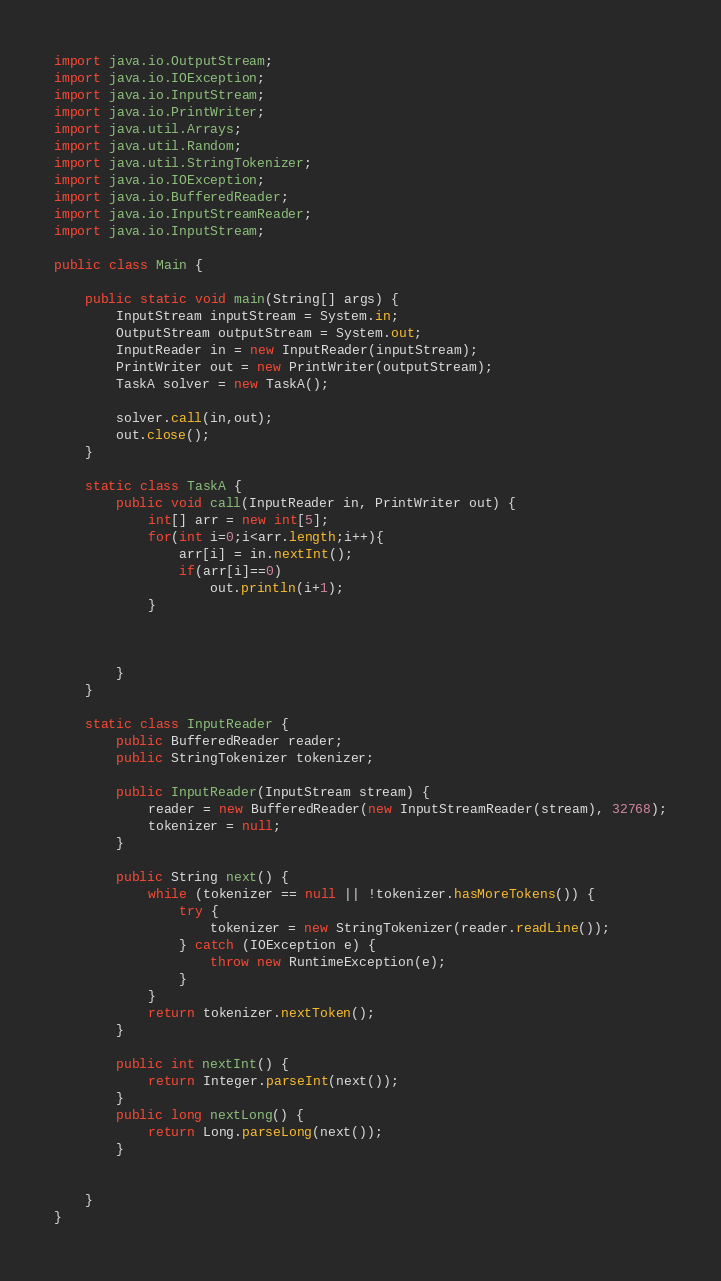Convert code to text. <code><loc_0><loc_0><loc_500><loc_500><_Java_>import java.io.OutputStream;
import java.io.IOException;
import java.io.InputStream;
import java.io.PrintWriter;
import java.util.Arrays;
import java.util.Random;
import java.util.StringTokenizer;
import java.io.IOException;
import java.io.BufferedReader;
import java.io.InputStreamReader;
import java.io.InputStream;

public class Main {

    public static void main(String[] args) {
        InputStream inputStream = System.in;
        OutputStream outputStream = System.out;
        InputReader in = new InputReader(inputStream);
        PrintWriter out = new PrintWriter(outputStream);
        TaskA solver = new TaskA();

        solver.call(in,out);
        out.close();
    }

    static class TaskA {
        public void call(InputReader in, PrintWriter out) {
            int[] arr = new int[5];
            for(int i=0;i<arr.length;i++){
                arr[i] = in.nextInt();
                if(arr[i]==0)
                    out.println(i+1);
            }



        }
    }

    static class InputReader {
        public BufferedReader reader;
        public StringTokenizer tokenizer;

        public InputReader(InputStream stream) {
            reader = new BufferedReader(new InputStreamReader(stream), 32768);
            tokenizer = null;
        }

        public String next() {
            while (tokenizer == null || !tokenizer.hasMoreTokens()) {
                try {
                    tokenizer = new StringTokenizer(reader.readLine());
                } catch (IOException e) {
                    throw new RuntimeException(e);
                }
            }
            return tokenizer.nextToken();
        }

        public int nextInt() {
            return Integer.parseInt(next());
        }
        public long nextLong() {
            return Long.parseLong(next());
        }


    }
}</code> 